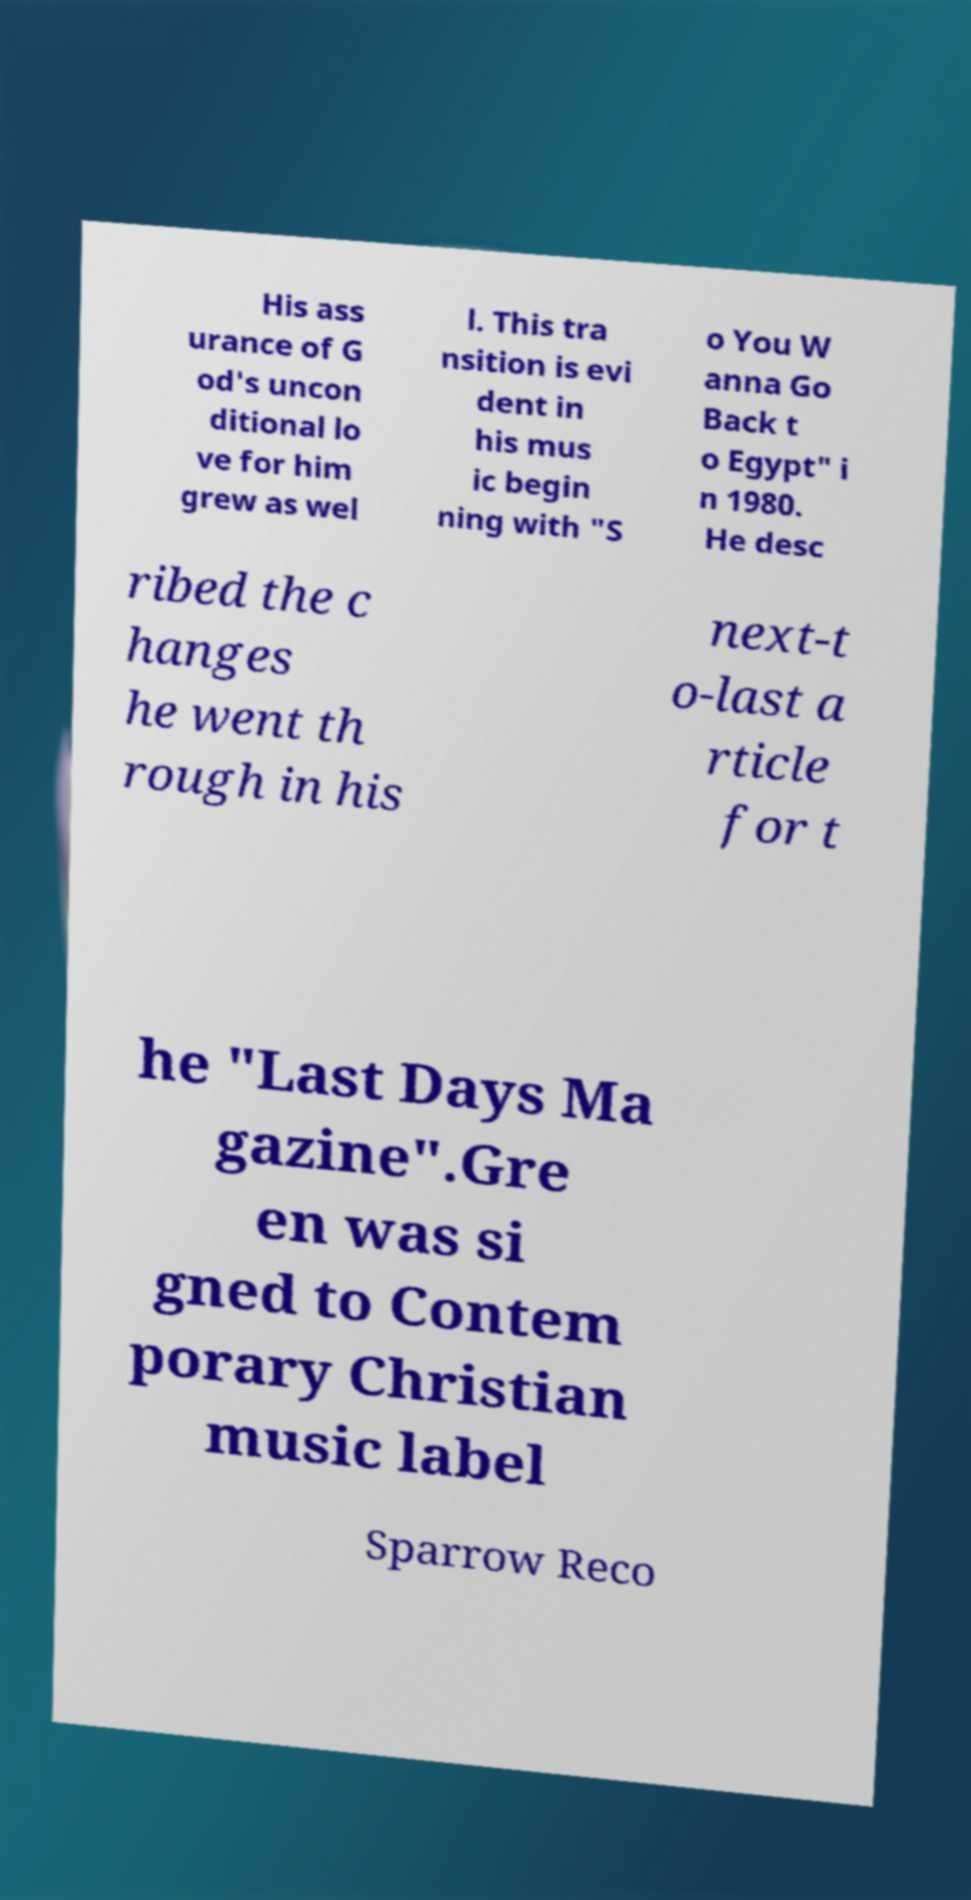Please identify and transcribe the text found in this image. His ass urance of G od's uncon ditional lo ve for him grew as wel l. This tra nsition is evi dent in his mus ic begin ning with "S o You W anna Go Back t o Egypt" i n 1980. He desc ribed the c hanges he went th rough in his next-t o-last a rticle for t he "Last Days Ma gazine".Gre en was si gned to Contem porary Christian music label Sparrow Reco 